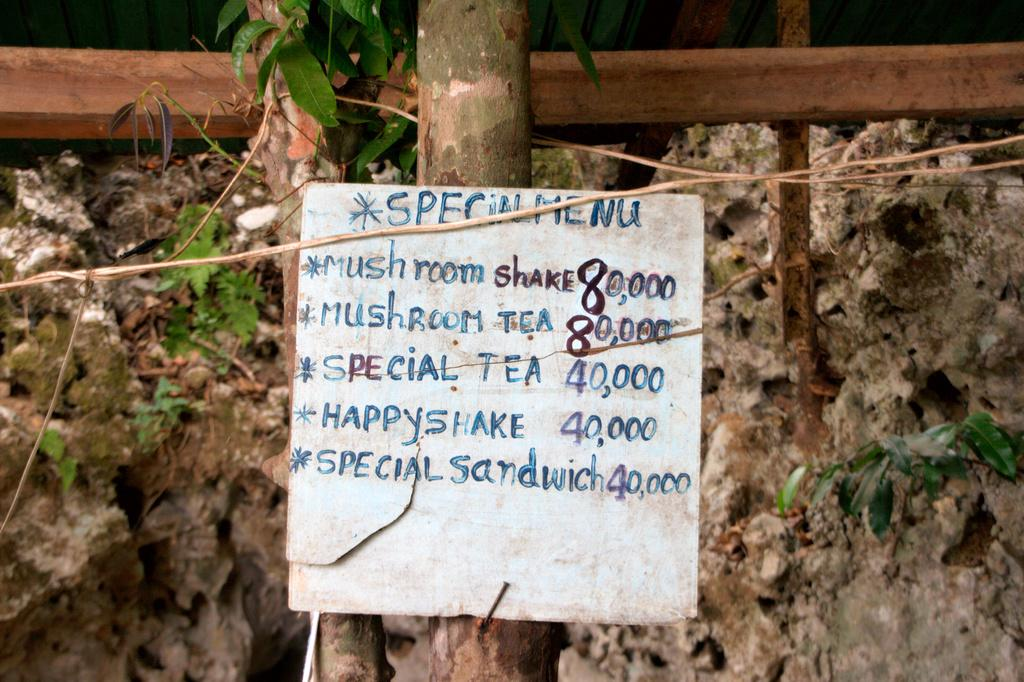What is attached to the tree in the image? There is a board on a tree in the image. What can be seen in the background of the image? There is a wall and plants visible in the background of the image. What object is present in the image that might be used for support or hanging? There is a rod in the image. How does the board help with the digestion of the tree in the image? The board does not have any impact on the tree's digestion, as trees do not have a digestive system. 